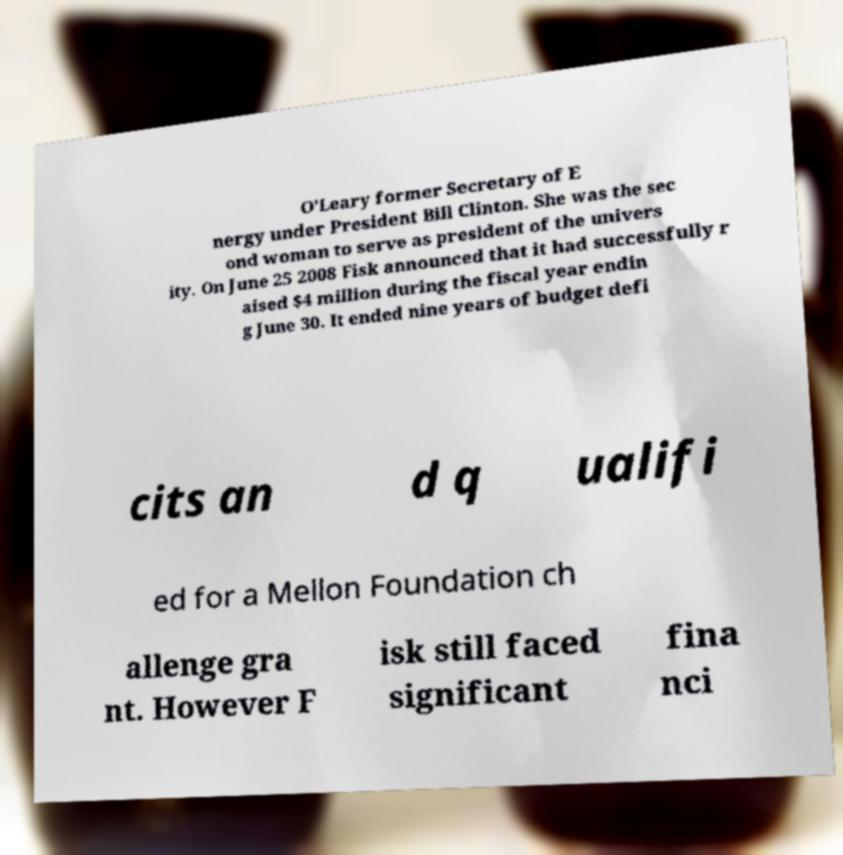Could you assist in decoding the text presented in this image and type it out clearly? O'Leary former Secretary of E nergy under President Bill Clinton. She was the sec ond woman to serve as president of the univers ity. On June 25 2008 Fisk announced that it had successfully r aised $4 million during the fiscal year endin g June 30. It ended nine years of budget defi cits an d q ualifi ed for a Mellon Foundation ch allenge gra nt. However F isk still faced significant fina nci 